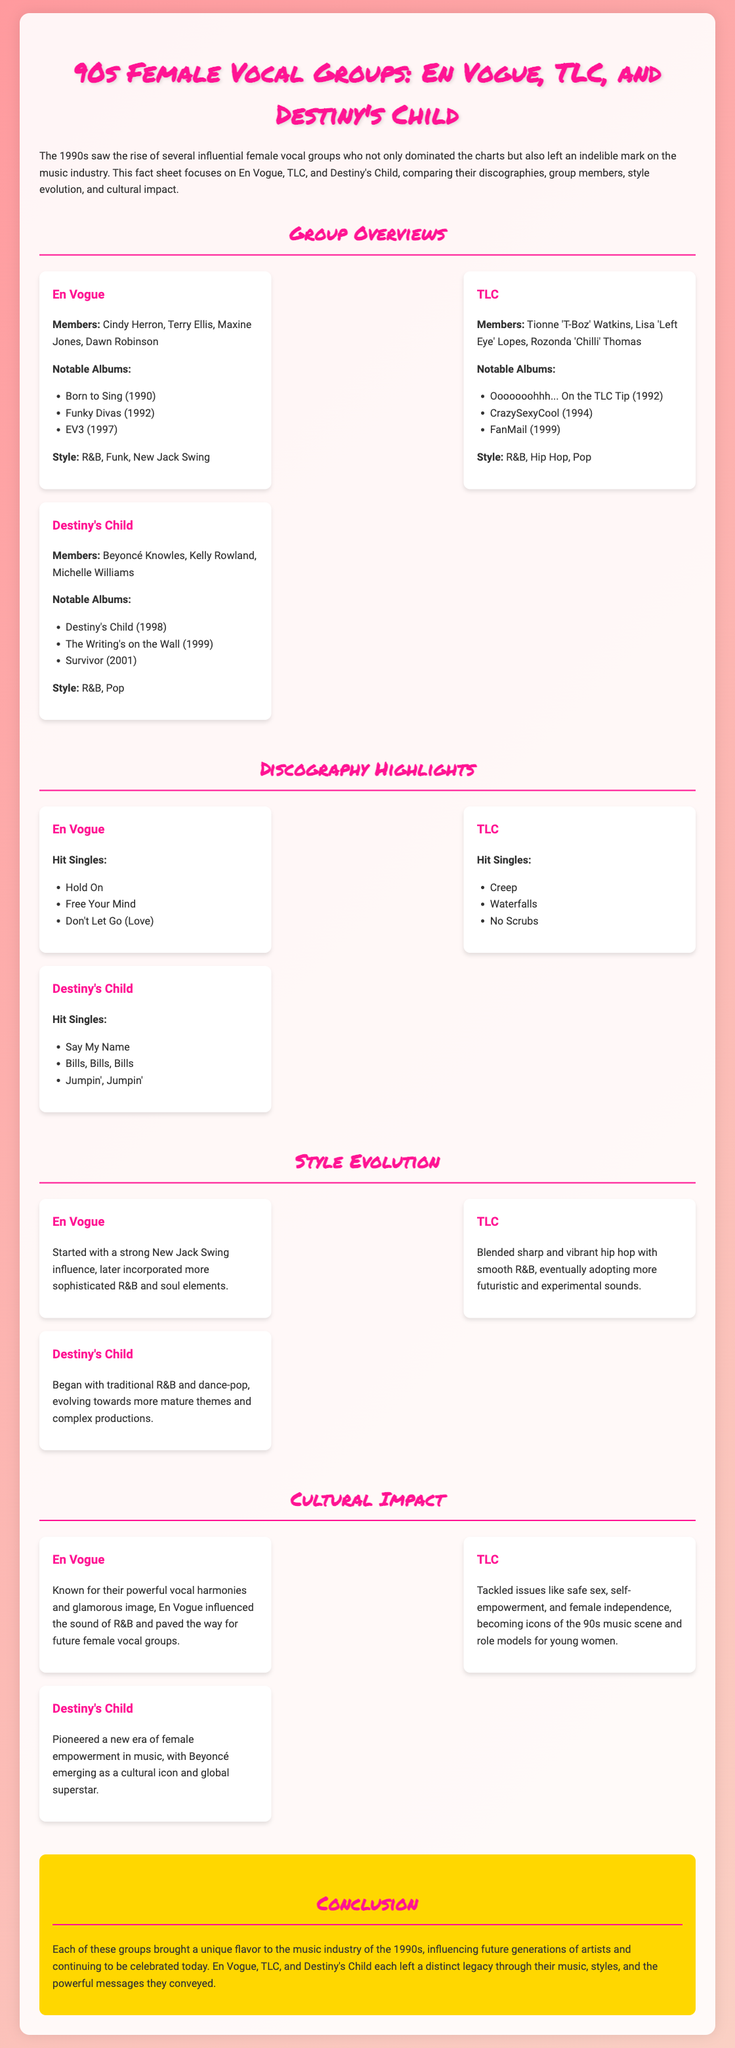What are the names of the members of En Vogue? The members of En Vogue are Cindy Herron, Terry Ellis, Maxine Jones, and Dawn Robinson.
Answer: Cindy Herron, Terry Ellis, Maxine Jones, Dawn Robinson How many notable albums does TLC have listed? TLC has three notable albums listed in the document.
Answer: 3 Which group has the hit single "Waterfalls"? "Waterfalls" is one of the hit singles listed under TLC.
Answer: TLC What genre did En Vogue start with? En Vogue started with a strong New Jack Swing influence.
Answer: New Jack Swing Which group is associated with the song "Say My Name"? "Say My Name" is associated with Destiny's Child as one of their hit singles.
Answer: Destiny's Child What significant issues did TLC address in their music? TLC tackled issues like safe sex, self-empowerment, and female independence.
Answer: Safe sex, self-empowerment, and female independence Which group's style evolved towards more mature themes and complex productions? The style of Destiny's Child evolved towards more mature themes and complex productions.
Answer: Destiny's Child What cultural role did TLC play in the 90s music scene? TLC became icons of the 90s music scene and role models for young women.
Answer: Icons of the 90s music scene and role models for young women 